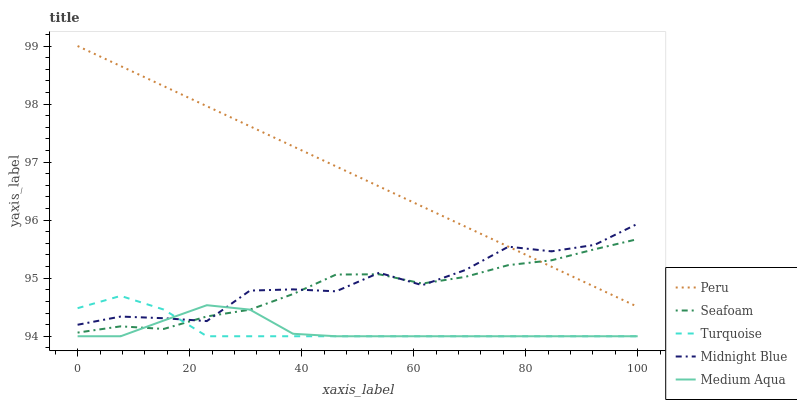Does Medium Aqua have the minimum area under the curve?
Answer yes or no. Yes. Does Peru have the maximum area under the curve?
Answer yes or no. Yes. Does Seafoam have the minimum area under the curve?
Answer yes or no. No. Does Seafoam have the maximum area under the curve?
Answer yes or no. No. Is Peru the smoothest?
Answer yes or no. Yes. Is Midnight Blue the roughest?
Answer yes or no. Yes. Is Medium Aqua the smoothest?
Answer yes or no. No. Is Medium Aqua the roughest?
Answer yes or no. No. Does Turquoise have the lowest value?
Answer yes or no. Yes. Does Seafoam have the lowest value?
Answer yes or no. No. Does Peru have the highest value?
Answer yes or no. Yes. Does Seafoam have the highest value?
Answer yes or no. No. Is Turquoise less than Peru?
Answer yes or no. Yes. Is Peru greater than Turquoise?
Answer yes or no. Yes. Does Midnight Blue intersect Peru?
Answer yes or no. Yes. Is Midnight Blue less than Peru?
Answer yes or no. No. Is Midnight Blue greater than Peru?
Answer yes or no. No. Does Turquoise intersect Peru?
Answer yes or no. No. 